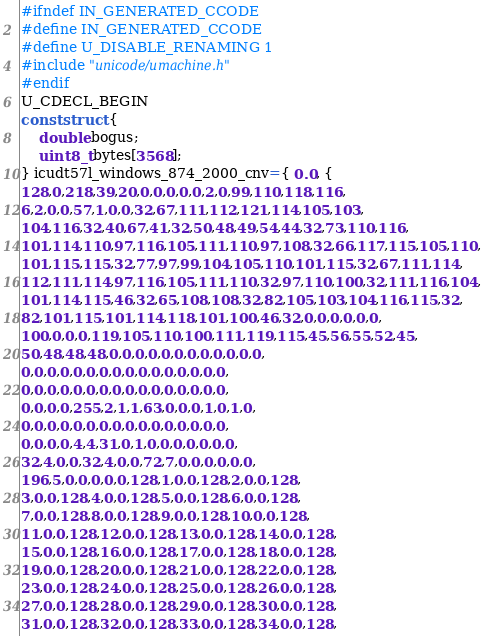Convert code to text. <code><loc_0><loc_0><loc_500><loc_500><_C_>#ifndef IN_GENERATED_CCODE
#define IN_GENERATED_CCODE
#define U_DISABLE_RENAMING 1
#include "unicode/umachine.h"
#endif
U_CDECL_BEGIN
const struct {
    double bogus;
    uint8_t bytes[3568]; 
} icudt57l_windows_874_2000_cnv={ 0.0, {
128,0,218,39,20,0,0,0,0,0,2,0,99,110,118,116,
6,2,0,0,57,1,0,0,32,67,111,112,121,114,105,103,
104,116,32,40,67,41,32,50,48,49,54,44,32,73,110,116,
101,114,110,97,116,105,111,110,97,108,32,66,117,115,105,110,
101,115,115,32,77,97,99,104,105,110,101,115,32,67,111,114,
112,111,114,97,116,105,111,110,32,97,110,100,32,111,116,104,
101,114,115,46,32,65,108,108,32,82,105,103,104,116,115,32,
82,101,115,101,114,118,101,100,46,32,0,0,0,0,0,0,
100,0,0,0,119,105,110,100,111,119,115,45,56,55,52,45,
50,48,48,48,0,0,0,0,0,0,0,0,0,0,0,0,
0,0,0,0,0,0,0,0,0,0,0,0,0,0,0,0,
0,0,0,0,0,0,0,0,0,0,0,0,0,0,0,0,
0,0,0,0,255,2,1,1,63,0,0,0,1,0,1,0,
0,0,0,0,0,0,0,0,0,0,0,0,0,0,0,0,
0,0,0,0,4,4,31,0,1,0,0,0,0,0,0,0,
32,4,0,0,32,4,0,0,72,7,0,0,0,0,0,0,
196,5,0,0,0,0,0,128,1,0,0,128,2,0,0,128,
3,0,0,128,4,0,0,128,5,0,0,128,6,0,0,128,
7,0,0,128,8,0,0,128,9,0,0,128,10,0,0,128,
11,0,0,128,12,0,0,128,13,0,0,128,14,0,0,128,
15,0,0,128,16,0,0,128,17,0,0,128,18,0,0,128,
19,0,0,128,20,0,0,128,21,0,0,128,22,0,0,128,
23,0,0,128,24,0,0,128,25,0,0,128,26,0,0,128,
27,0,0,128,28,0,0,128,29,0,0,128,30,0,0,128,
31,0,0,128,32,0,0,128,33,0,0,128,34,0,0,128,</code> 